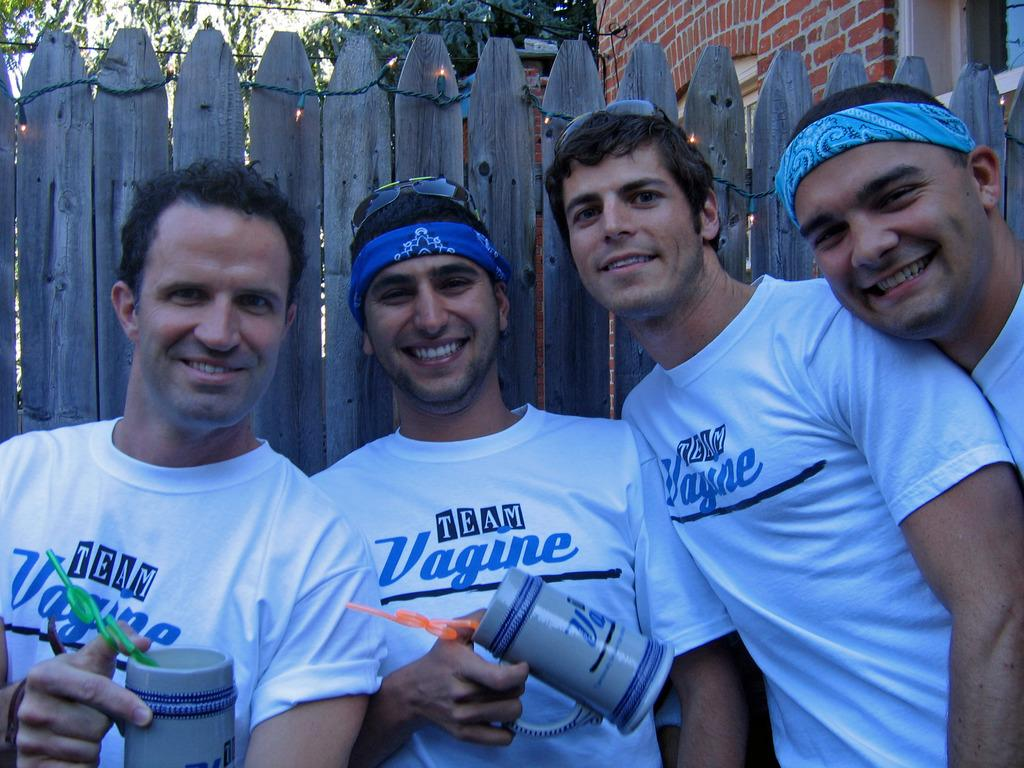<image>
Offer a succinct explanation of the picture presented. A group of men posing next to a fence all wearing a t-shirt with the logo TEAM Vagine on them. 